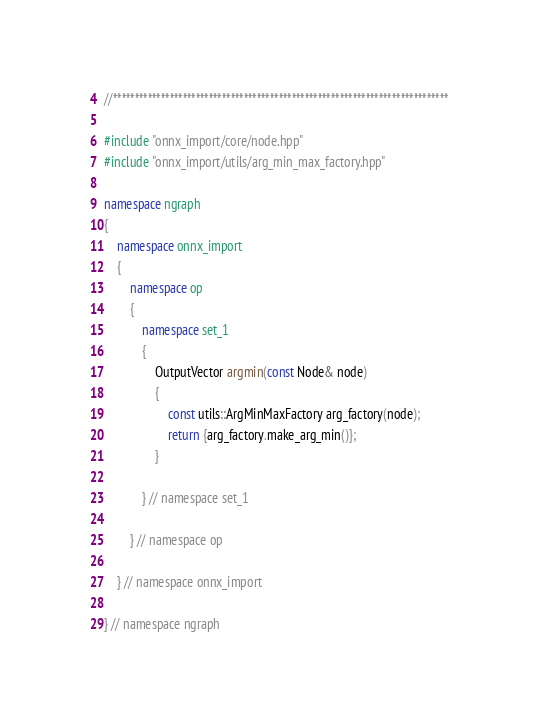Convert code to text. <code><loc_0><loc_0><loc_500><loc_500><_C++_>//*****************************************************************************

#include "onnx_import/core/node.hpp"
#include "onnx_import/utils/arg_min_max_factory.hpp"

namespace ngraph
{
    namespace onnx_import
    {
        namespace op
        {
            namespace set_1
            {
                OutputVector argmin(const Node& node)
                {
                    const utils::ArgMinMaxFactory arg_factory(node);
                    return {arg_factory.make_arg_min()};
                }

            } // namespace set_1

        } // namespace op

    } // namespace onnx_import

} // namespace ngraph
</code> 